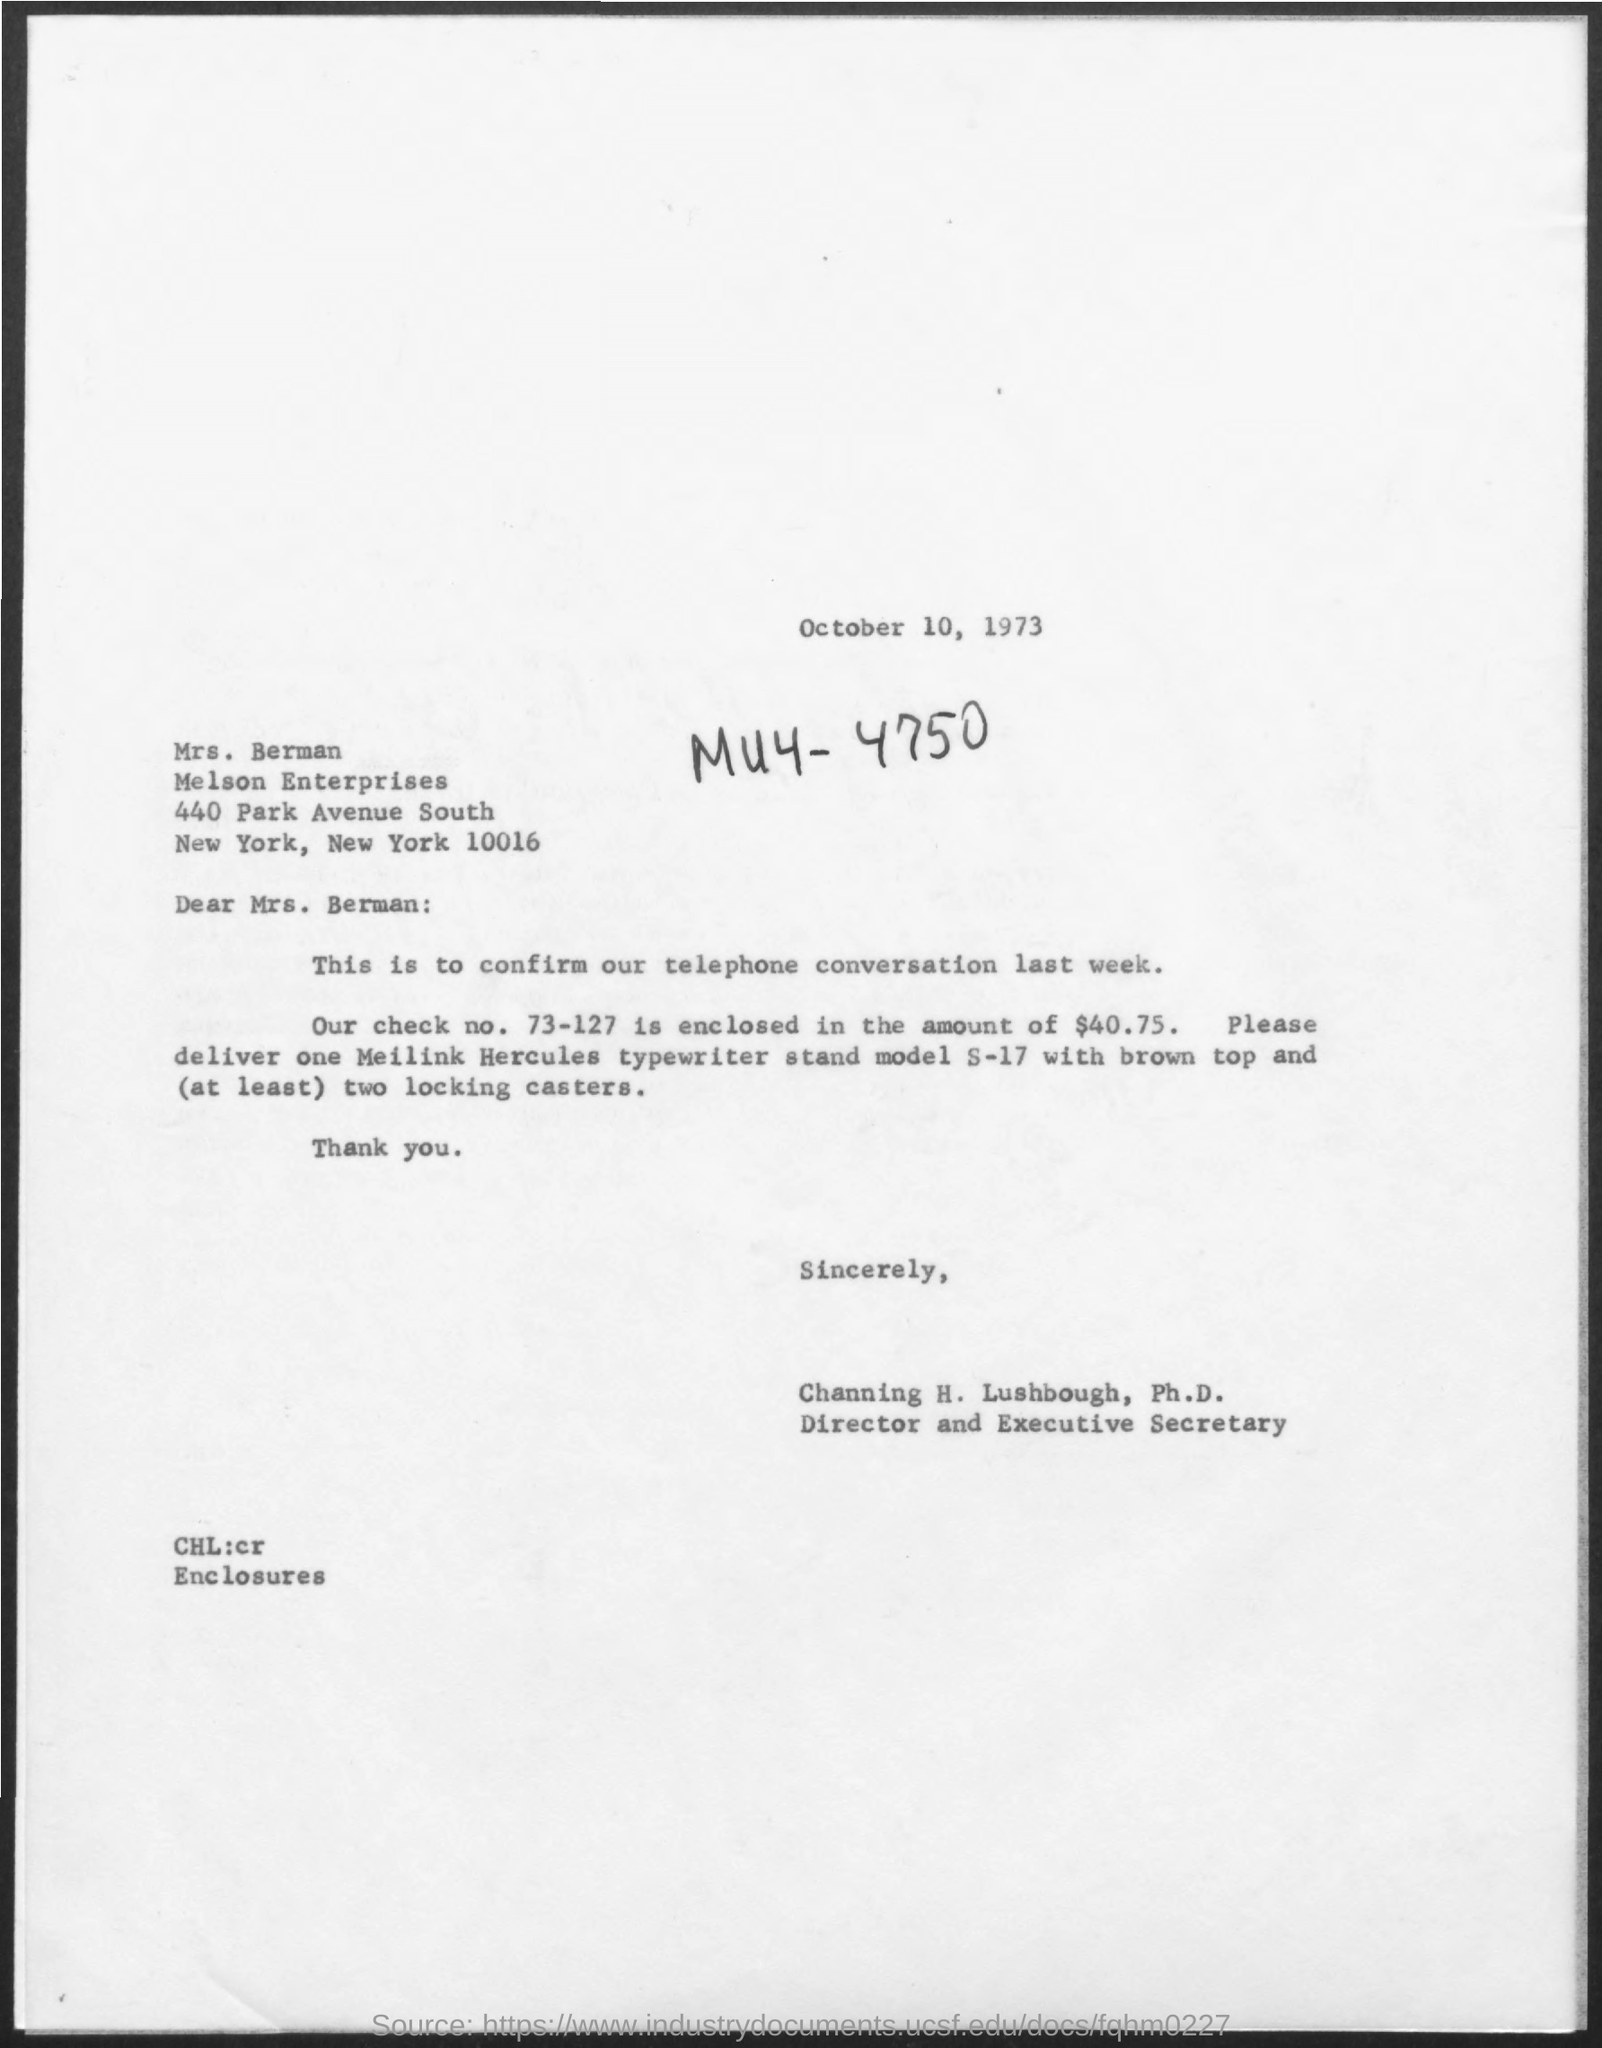Point out several critical features in this image. The letter was sent to Mrs. Berman. Channing H. Lushbough is both the director and executive secretary of a designated entity. The date mentioned in the given page is October 10, 1973. The check number mentioned is 73-127. The enterprise mentioned is named "Melson Enterprises. 